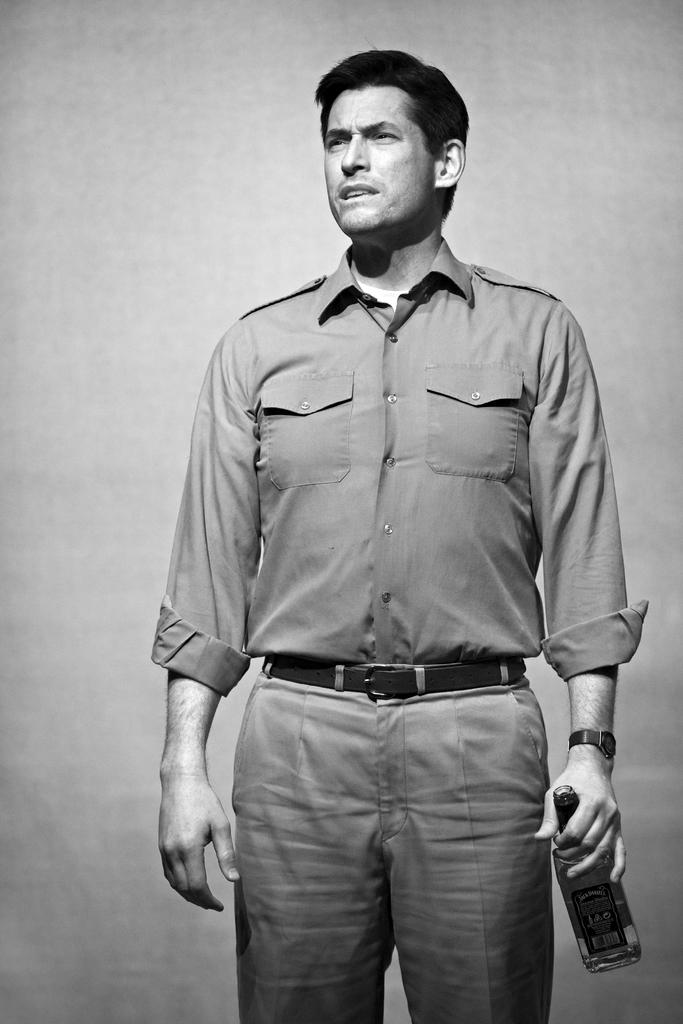Who is present in the image? There is a man in the image. What is the man holding in his right hand? The man is holding a bottle in his right hand. Who is the man looking at? The man is looking at someone. What type of sofa is visible in the image? There is no sofa present in the image. What game is the man playing in the image? There is no game being played in the image. 